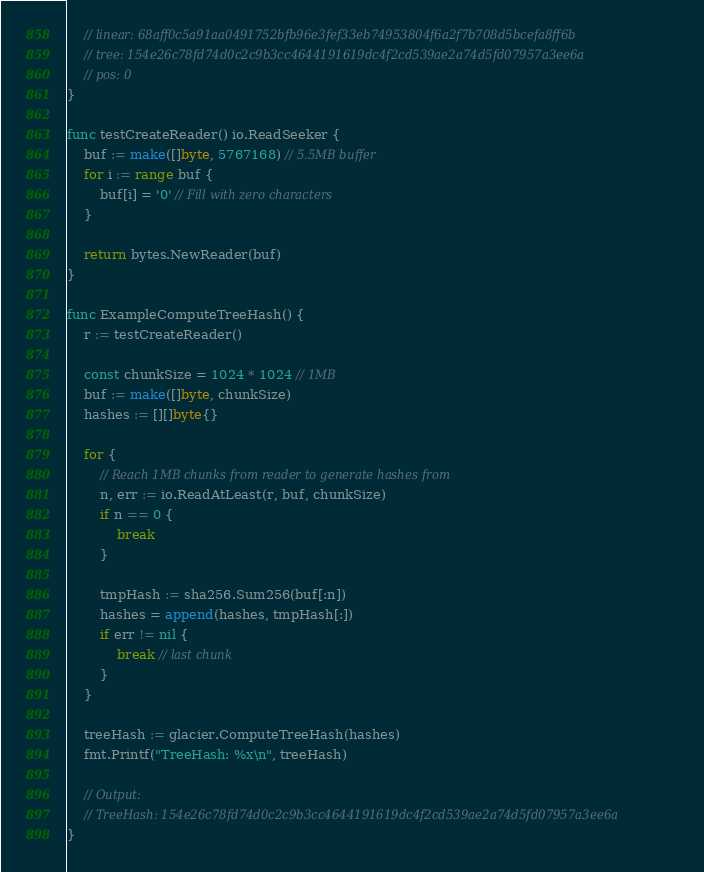<code> <loc_0><loc_0><loc_500><loc_500><_Go_>	// linear: 68aff0c5a91aa0491752bfb96e3fef33eb74953804f6a2f7b708d5bcefa8ff6b
	// tree: 154e26c78fd74d0c2c9b3cc4644191619dc4f2cd539ae2a74d5fd07957a3ee6a
	// pos: 0
}

func testCreateReader() io.ReadSeeker {
	buf := make([]byte, 5767168) // 5.5MB buffer
	for i := range buf {
		buf[i] = '0' // Fill with zero characters
	}

	return bytes.NewReader(buf)
}

func ExampleComputeTreeHash() {
	r := testCreateReader()

	const chunkSize = 1024 * 1024 // 1MB
	buf := make([]byte, chunkSize)
	hashes := [][]byte{}

	for {
		// Reach 1MB chunks from reader to generate hashes from
		n, err := io.ReadAtLeast(r, buf, chunkSize)
		if n == 0 {
			break
		}

		tmpHash := sha256.Sum256(buf[:n])
		hashes = append(hashes, tmpHash[:])
		if err != nil {
			break // last chunk
		}
	}

	treeHash := glacier.ComputeTreeHash(hashes)
	fmt.Printf("TreeHash: %x\n", treeHash)

	// Output:
	// TreeHash: 154e26c78fd74d0c2c9b3cc4644191619dc4f2cd539ae2a74d5fd07957a3ee6a
}
</code> 